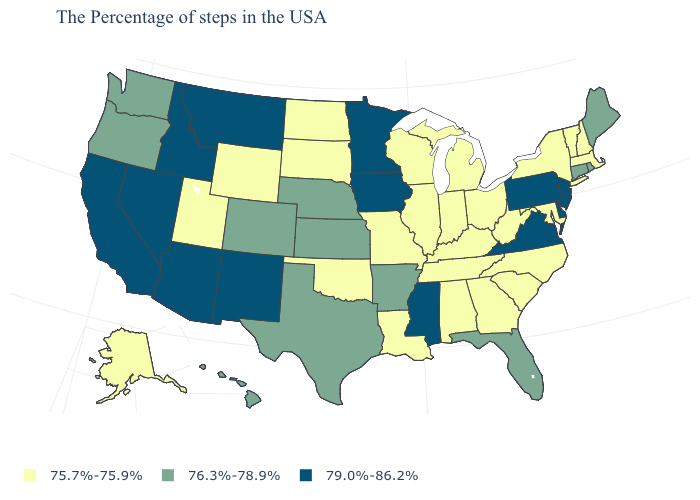What is the value of Missouri?
Be succinct. 75.7%-75.9%. Which states hav the highest value in the West?
Keep it brief. New Mexico, Montana, Arizona, Idaho, Nevada, California. Does Arizona have a lower value than Maryland?
Give a very brief answer. No. Which states have the lowest value in the West?
Keep it brief. Wyoming, Utah, Alaska. Which states have the lowest value in the USA?
Be succinct. Massachusetts, New Hampshire, Vermont, New York, Maryland, North Carolina, South Carolina, West Virginia, Ohio, Georgia, Michigan, Kentucky, Indiana, Alabama, Tennessee, Wisconsin, Illinois, Louisiana, Missouri, Oklahoma, South Dakota, North Dakota, Wyoming, Utah, Alaska. Name the states that have a value in the range 75.7%-75.9%?
Answer briefly. Massachusetts, New Hampshire, Vermont, New York, Maryland, North Carolina, South Carolina, West Virginia, Ohio, Georgia, Michigan, Kentucky, Indiana, Alabama, Tennessee, Wisconsin, Illinois, Louisiana, Missouri, Oklahoma, South Dakota, North Dakota, Wyoming, Utah, Alaska. Name the states that have a value in the range 76.3%-78.9%?
Answer briefly. Maine, Rhode Island, Connecticut, Florida, Arkansas, Kansas, Nebraska, Texas, Colorado, Washington, Oregon, Hawaii. Does Minnesota have the same value as Maryland?
Keep it brief. No. What is the highest value in the South ?
Give a very brief answer. 79.0%-86.2%. What is the value of Massachusetts?
Be succinct. 75.7%-75.9%. What is the value of Oregon?
Write a very short answer. 76.3%-78.9%. What is the value of Ohio?
Be succinct. 75.7%-75.9%. Does Rhode Island have the lowest value in the USA?
Be succinct. No. Name the states that have a value in the range 76.3%-78.9%?
Give a very brief answer. Maine, Rhode Island, Connecticut, Florida, Arkansas, Kansas, Nebraska, Texas, Colorado, Washington, Oregon, Hawaii. 